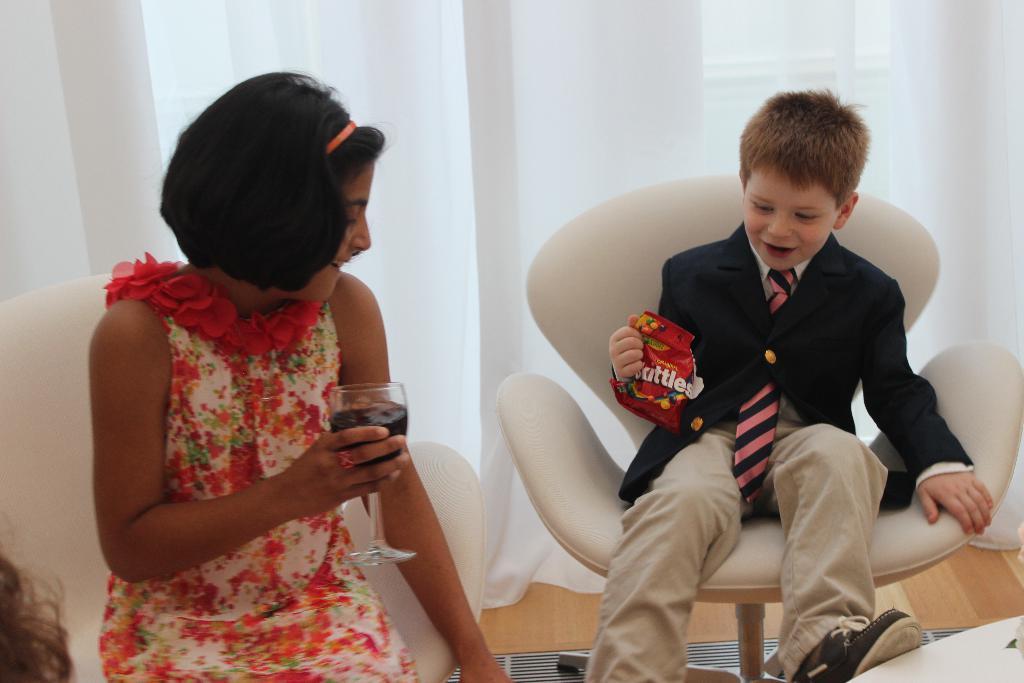Could you give a brief overview of what you see in this image? In this picture we can see two people holding a glass, packet with their hands, sitting on chairs and in the background we can see the floor, window with curtains. 